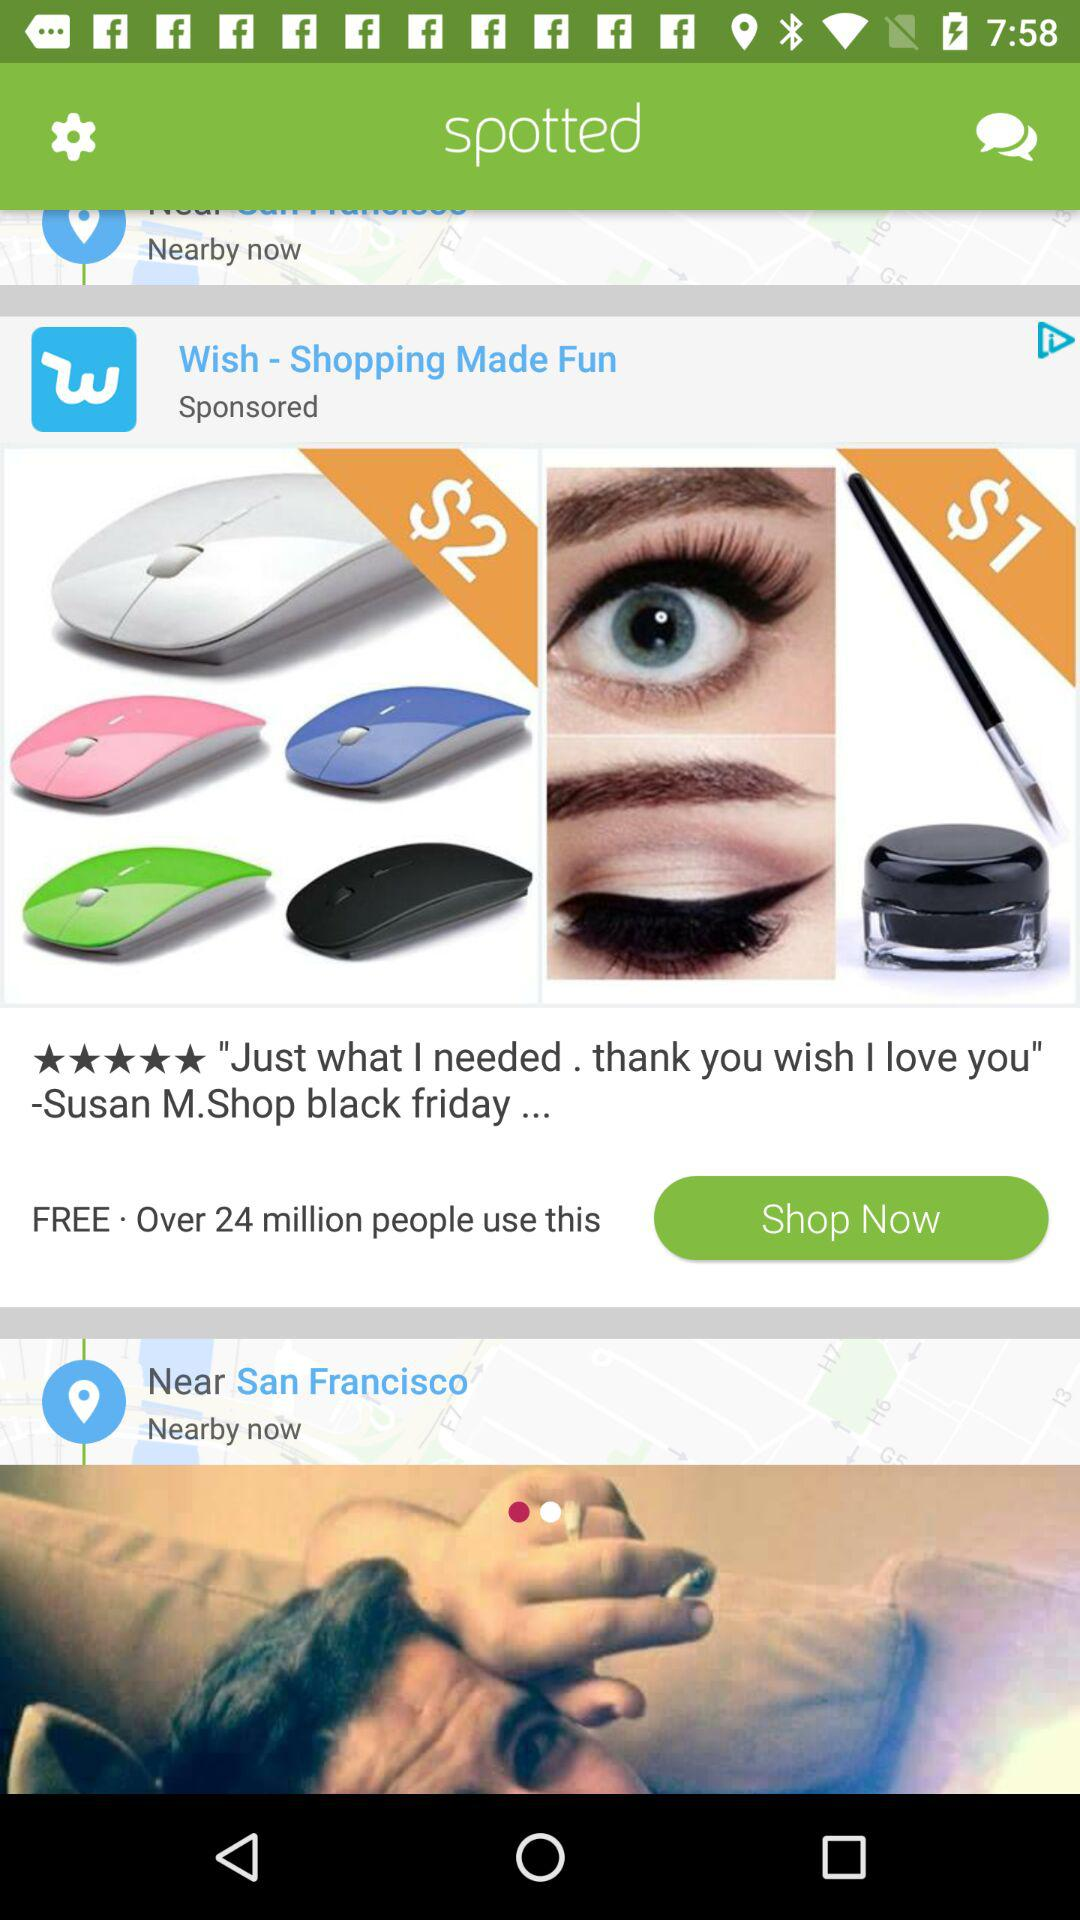What is the location? The location is San Francisco. 